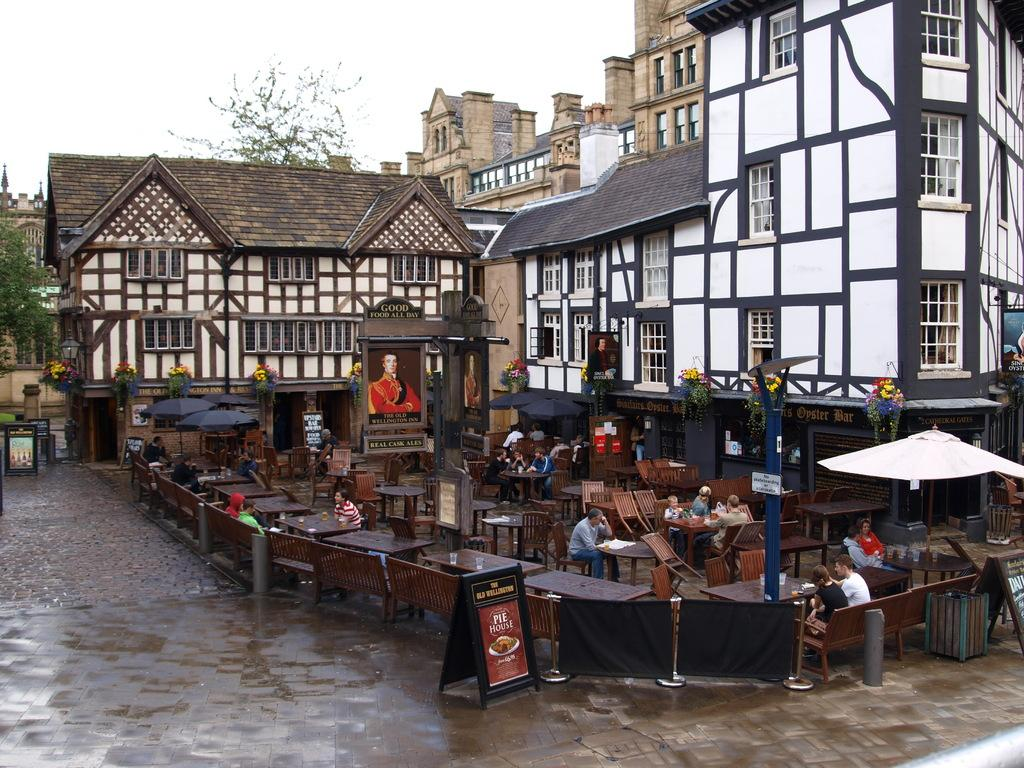<image>
Relay a brief, clear account of the picture shown. People sit outside at the Old Wellington Inn at tables. 